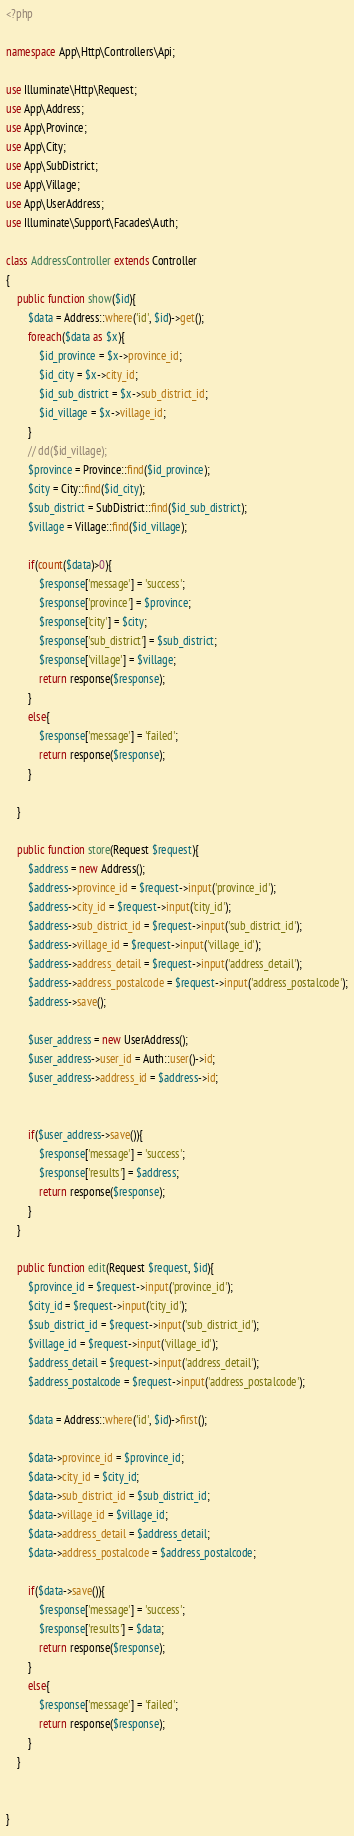Convert code to text. <code><loc_0><loc_0><loc_500><loc_500><_PHP_><?php

namespace App\Http\Controllers\Api;

use Illuminate\Http\Request;
use App\Address;
use App\Province;
use App\City;
use App\SubDistrict;
use App\Village;
use App\UserAddress;
use Illuminate\Support\Facades\Auth;

class AddressController extends Controller
{
    public function show($id){
        $data = Address::where('id', $id)->get();        
        foreach($data as $x){                
            $id_province = $x->province_id;
            $id_city = $x->city_id;
            $id_sub_district = $x->sub_district_id;            
            $id_village = $x->village_id;
        }
        // dd($id_village);
        $province = Province::find($id_province);
        $city = City::find($id_city);                    
        $sub_district = SubDistrict::find($id_sub_district);
        $village = Village::find($id_village); 

        if(count($data)>0){
            $response['message'] = 'success';
            $response['province'] = $province;
            $response['city'] = $city;
            $response['sub_district'] = $sub_district;
            $response['village'] = $village;
            return response($response);
        }
        else{
            $response['message'] = 'failed';
            return response($response);
        }

    }

    public function store(Request $request){
        $address = new Address();
        $address->province_id = $request->input('province_id');
        $address->city_id = $request->input('city_id');
        $address->sub_district_id = $request->input('sub_district_id');
        $address->village_id = $request->input('village_id');
        $address->address_detail = $request->input('address_detail');
        $address->address_postalcode = $request->input('address_postalcode');
        $address->save();

        $user_address = new UserAddress();
        $user_address->user_id = Auth::user()->id;
        $user_address->address_id = $address->id;


        if($user_address->save()){
            $response['message'] = 'success';
            $response['results'] = $address;
            return response($response);
        }
    }

    public function edit(Request $request, $id){          
        $province_id = $request->input('province_id');
        $city_id = $request->input('city_id');
        $sub_district_id = $request->input('sub_district_id');
        $village_id = $request->input('village_id');
        $address_detail = $request->input('address_detail');
        $address_postalcode = $request->input('address_postalcode');

        $data = Address::where('id', $id)->first();        

        $data->province_id = $province_id;
        $data->city_id = $city_id;
        $data->sub_district_id = $sub_district_id;
        $data->village_id = $village_id;
        $data->address_detail = $address_detail;
        $data->address_postalcode = $address_postalcode;

        if($data->save()){
            $response['message'] = 'success';
            $response['results'] = $data;
            return response($response);
        }
        else{
            $response['message'] = 'failed';
            return response($response);
        }
    }


}
</code> 